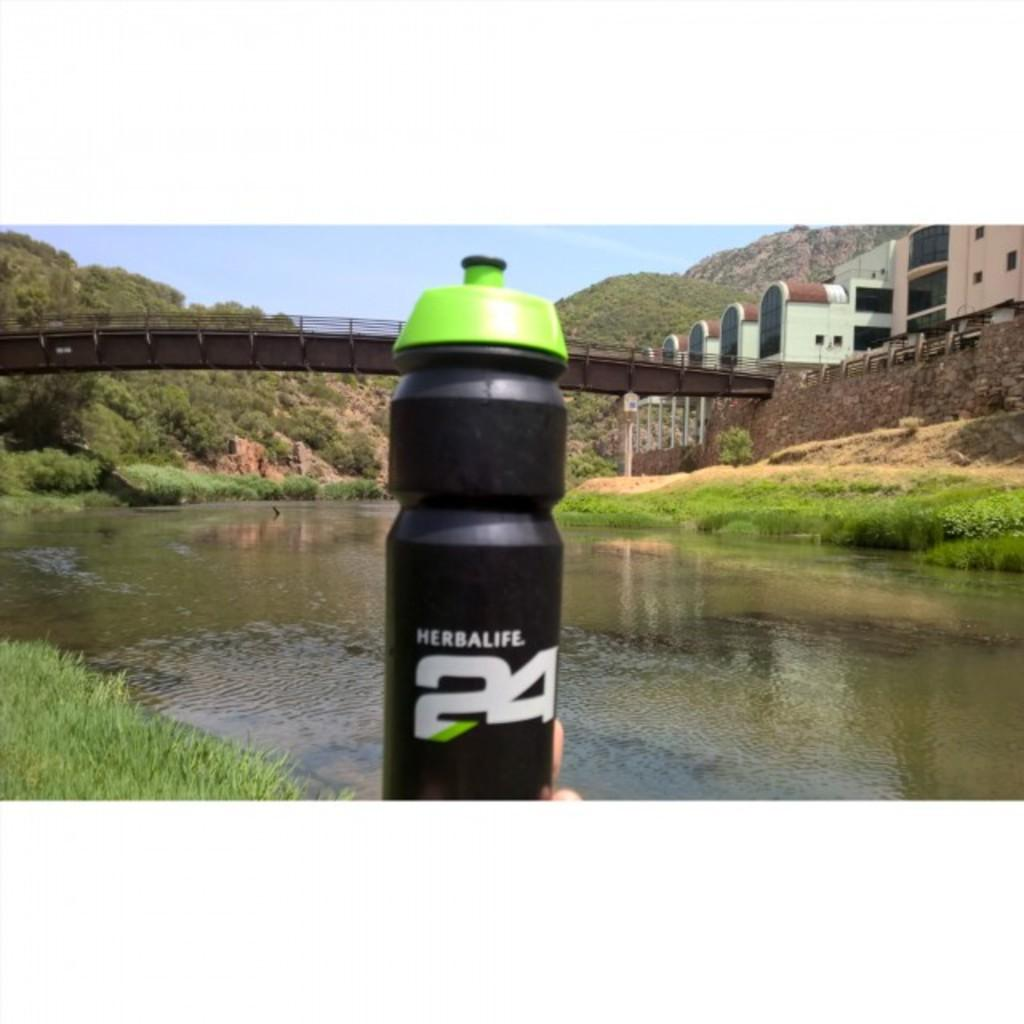What type of bottle is in the image? There is a sipper bottle in the image. What color is the sipper bottle? The sipper bottle is black in color. What color is the top part of the sipper bottle? The top of the sipper bottle is green. What can be seen inside the sipper bottle? There is water visible in the image. What is visible in the background of the image? There are buildings in the background of the image. Can you tell me where the toy is located in the image? There is no toy present in the image. Is there a seat visible in the image? There is no seat visible in the image. 